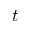<formula> <loc_0><loc_0><loc_500><loc_500>t</formula> 